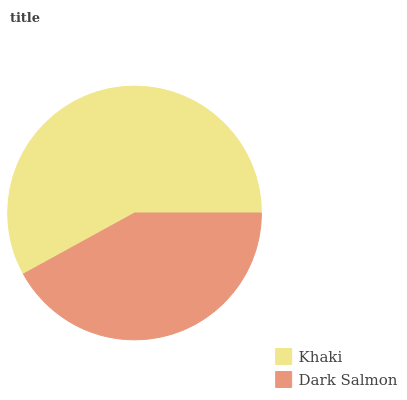Is Dark Salmon the minimum?
Answer yes or no. Yes. Is Khaki the maximum?
Answer yes or no. Yes. Is Dark Salmon the maximum?
Answer yes or no. No. Is Khaki greater than Dark Salmon?
Answer yes or no. Yes. Is Dark Salmon less than Khaki?
Answer yes or no. Yes. Is Dark Salmon greater than Khaki?
Answer yes or no. No. Is Khaki less than Dark Salmon?
Answer yes or no. No. Is Khaki the high median?
Answer yes or no. Yes. Is Dark Salmon the low median?
Answer yes or no. Yes. Is Dark Salmon the high median?
Answer yes or no. No. Is Khaki the low median?
Answer yes or no. No. 